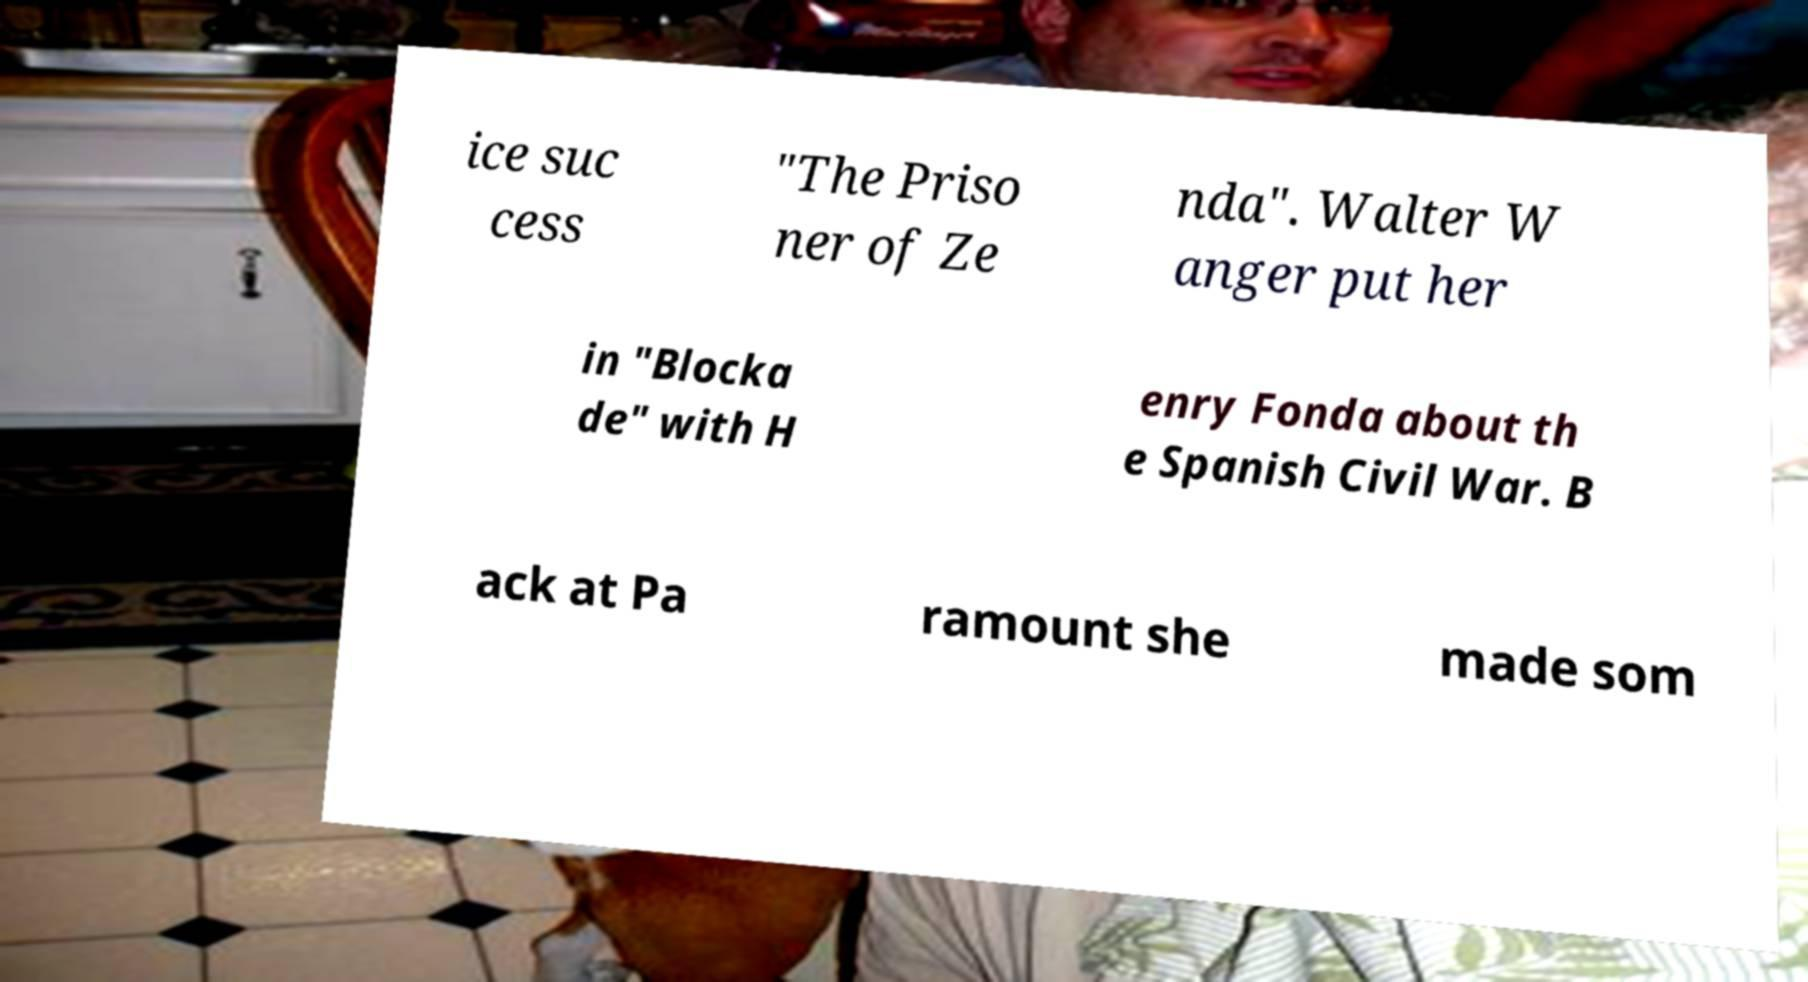Please read and relay the text visible in this image. What does it say? ice suc cess "The Priso ner of Ze nda". Walter W anger put her in "Blocka de" with H enry Fonda about th e Spanish Civil War. B ack at Pa ramount she made som 